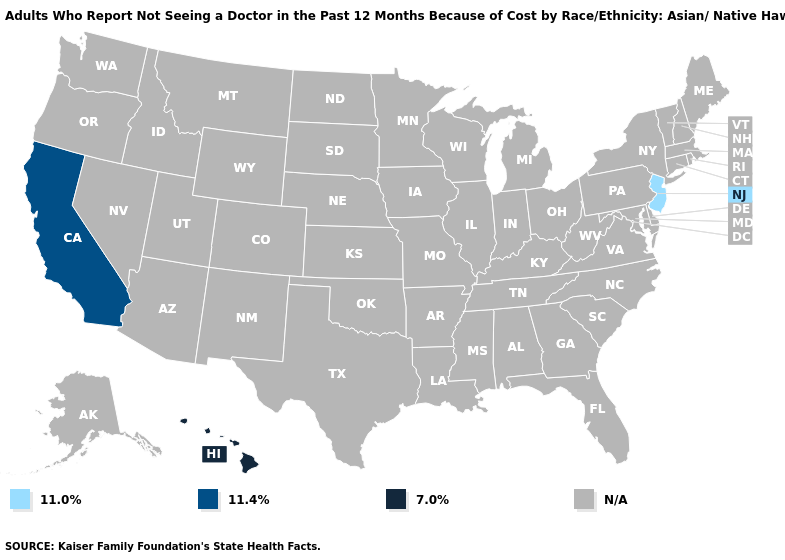Name the states that have a value in the range N/A?
Keep it brief. Alabama, Alaska, Arizona, Arkansas, Colorado, Connecticut, Delaware, Florida, Georgia, Idaho, Illinois, Indiana, Iowa, Kansas, Kentucky, Louisiana, Maine, Maryland, Massachusetts, Michigan, Minnesota, Mississippi, Missouri, Montana, Nebraska, Nevada, New Hampshire, New Mexico, New York, North Carolina, North Dakota, Ohio, Oklahoma, Oregon, Pennsylvania, Rhode Island, South Carolina, South Dakota, Tennessee, Texas, Utah, Vermont, Virginia, Washington, West Virginia, Wisconsin, Wyoming. Which states have the highest value in the USA?
Give a very brief answer. Hawaii. What is the value of Colorado?
Keep it brief. N/A. Which states have the lowest value in the West?
Answer briefly. California. What is the value of Utah?
Quick response, please. N/A. What is the value of Illinois?
Write a very short answer. N/A. What is the value of Virginia?
Give a very brief answer. N/A. What is the value of Ohio?
Quick response, please. N/A. What is the value of South Dakota?
Answer briefly. N/A. Name the states that have a value in the range N/A?
Short answer required. Alabama, Alaska, Arizona, Arkansas, Colorado, Connecticut, Delaware, Florida, Georgia, Idaho, Illinois, Indiana, Iowa, Kansas, Kentucky, Louisiana, Maine, Maryland, Massachusetts, Michigan, Minnesota, Mississippi, Missouri, Montana, Nebraska, Nevada, New Hampshire, New Mexico, New York, North Carolina, North Dakota, Ohio, Oklahoma, Oregon, Pennsylvania, Rhode Island, South Carolina, South Dakota, Tennessee, Texas, Utah, Vermont, Virginia, Washington, West Virginia, Wisconsin, Wyoming. Does the map have missing data?
Be succinct. Yes. Name the states that have a value in the range 11.0%?
Write a very short answer. New Jersey. 